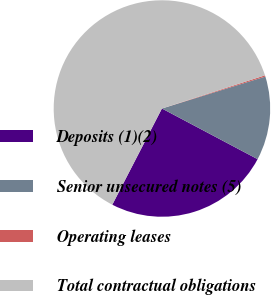Convert chart to OTSL. <chart><loc_0><loc_0><loc_500><loc_500><pie_chart><fcel>Deposits (1)(2)<fcel>Senior unsecured notes (5)<fcel>Operating leases<fcel>Total contractual obligations<nl><fcel>24.83%<fcel>12.52%<fcel>0.19%<fcel>62.46%<nl></chart> 